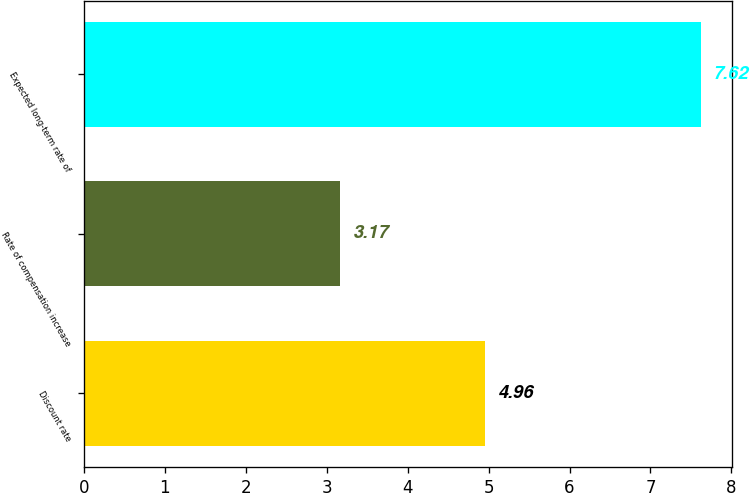Convert chart. <chart><loc_0><loc_0><loc_500><loc_500><bar_chart><fcel>Discount rate<fcel>Rate of compensation increase<fcel>Expected long-term rate of<nl><fcel>4.96<fcel>3.17<fcel>7.62<nl></chart> 